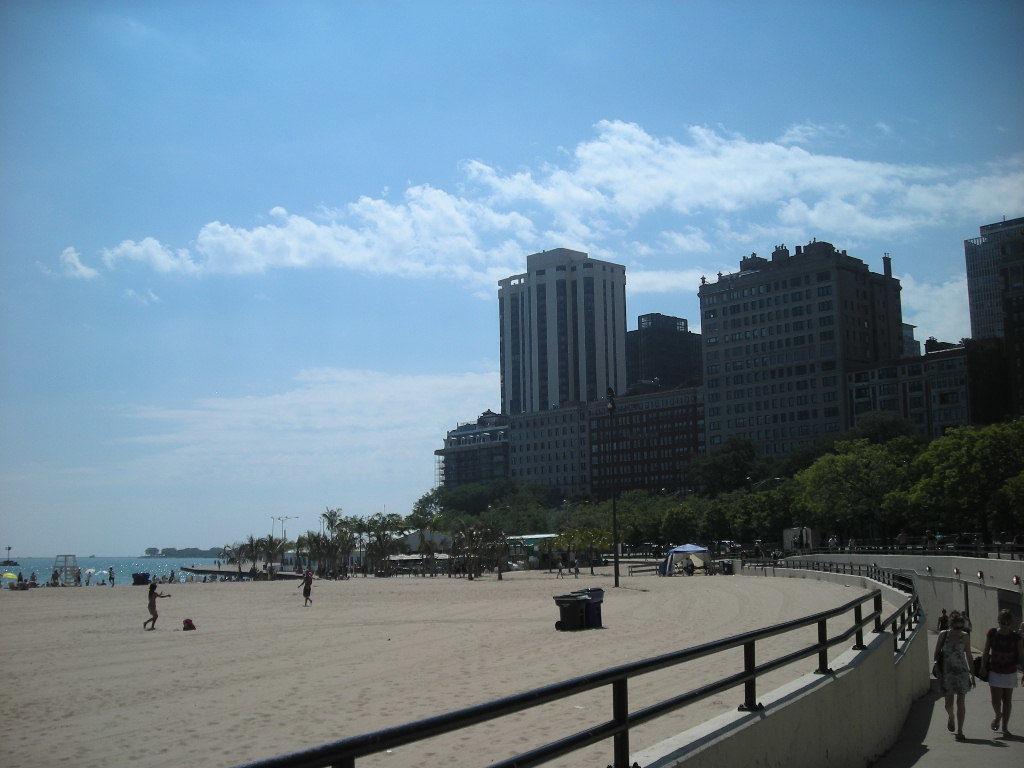Describe this image in one or two sentences. In the right corner of the image there are few people standing. Beside them there is a wall with railing. On the sand there are few people standing. And also there is a pole. In the image there are trees. Behind the trees there are buildings with glasses. And also there is water on the left side of the image. 